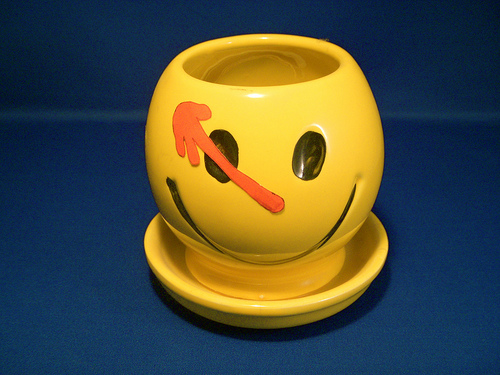<image>
Is the paint on the cup? Yes. Looking at the image, I can see the paint is positioned on top of the cup, with the cup providing support. 